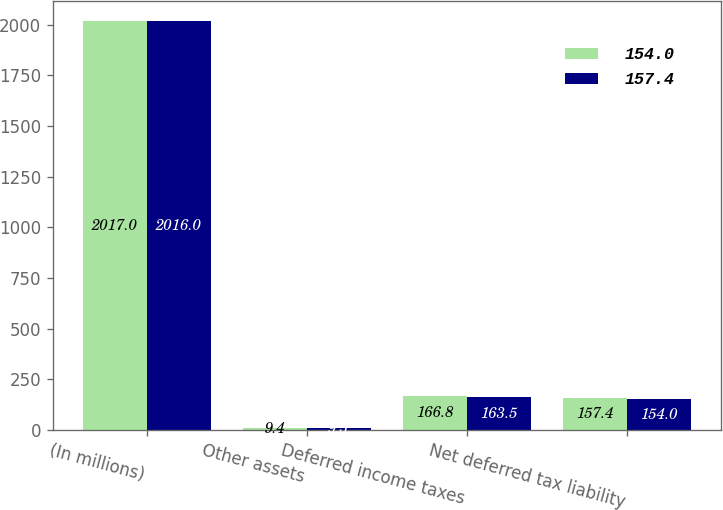Convert chart to OTSL. <chart><loc_0><loc_0><loc_500><loc_500><stacked_bar_chart><ecel><fcel>(In millions)<fcel>Other assets<fcel>Deferred income taxes<fcel>Net deferred tax liability<nl><fcel>154<fcel>2017<fcel>9.4<fcel>166.8<fcel>157.4<nl><fcel>157.4<fcel>2016<fcel>9.5<fcel>163.5<fcel>154<nl></chart> 